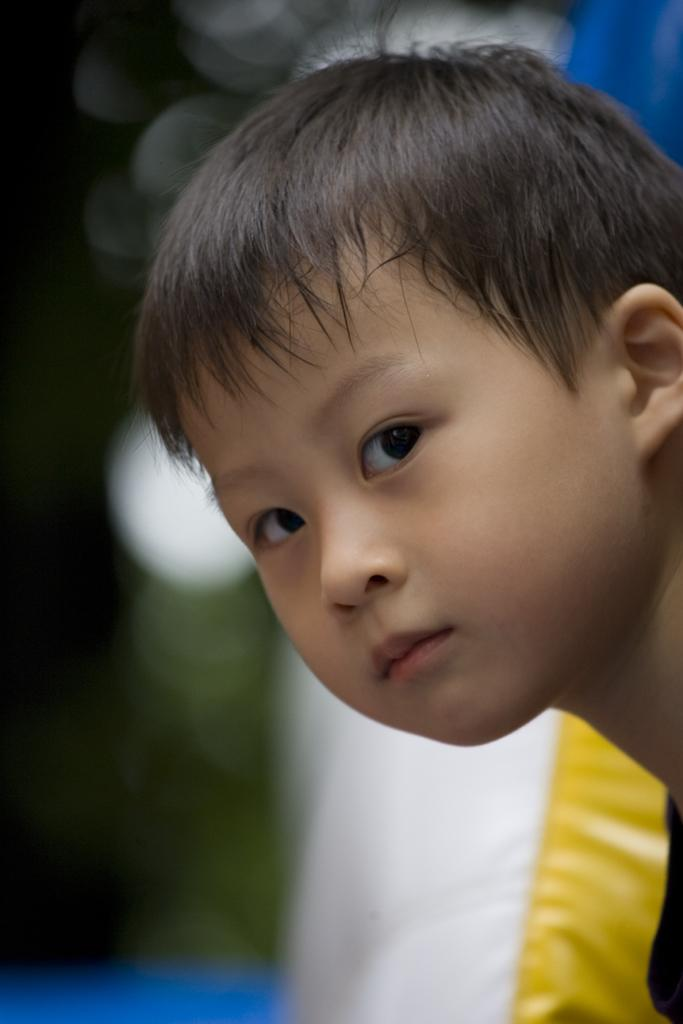What is the main subject of the image? There is a boy in the image. Can you describe the background of the image? The background of the image is blurred. What type of wilderness can be seen in the background of the image? There is no wilderness visible in the image, as the background is blurred. How does the boy compare to the scarecrow in the image? There is no scarecrow present in the image, so a comparison cannot be made. 